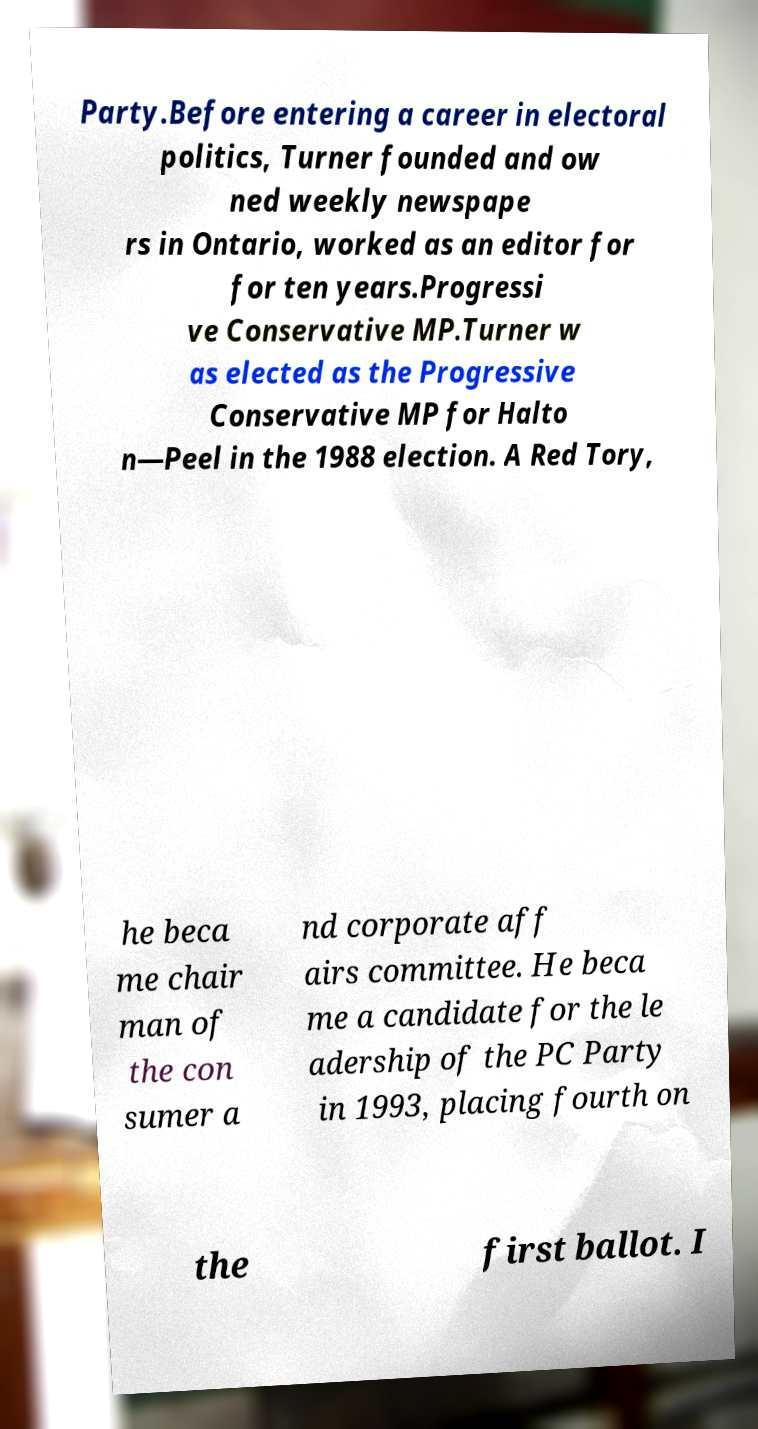For documentation purposes, I need the text within this image transcribed. Could you provide that? Party.Before entering a career in electoral politics, Turner founded and ow ned weekly newspape rs in Ontario, worked as an editor for for ten years.Progressi ve Conservative MP.Turner w as elected as the Progressive Conservative MP for Halto n—Peel in the 1988 election. A Red Tory, he beca me chair man of the con sumer a nd corporate aff airs committee. He beca me a candidate for the le adership of the PC Party in 1993, placing fourth on the first ballot. I 